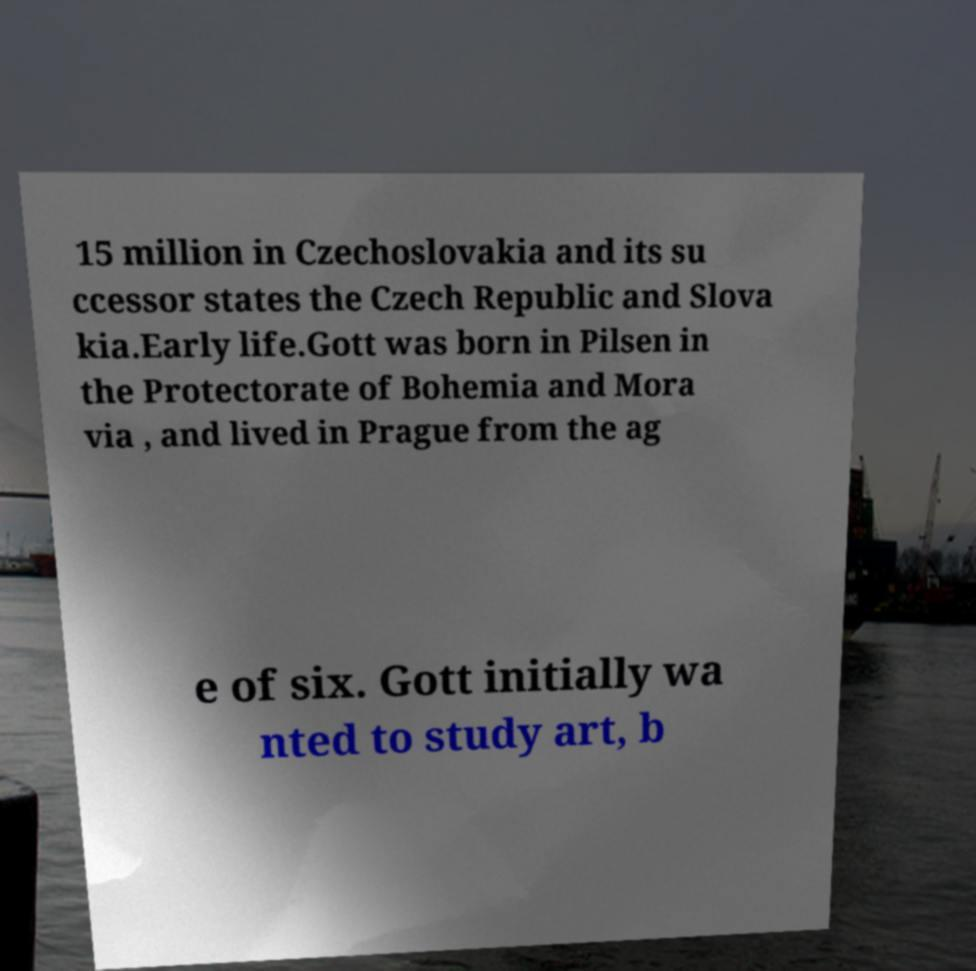Could you extract and type out the text from this image? 15 million in Czechoslovakia and its su ccessor states the Czech Republic and Slova kia.Early life.Gott was born in Pilsen in the Protectorate of Bohemia and Mora via , and lived in Prague from the ag e of six. Gott initially wa nted to study art, b 